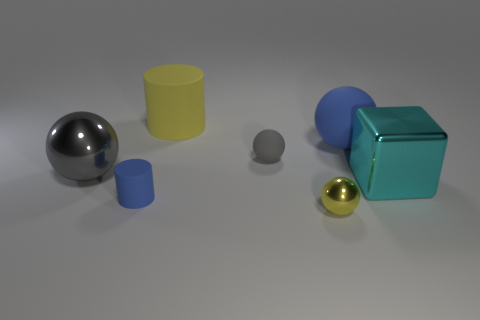What is the shape of the object that is both on the left side of the large yellow cylinder and in front of the big cyan thing?
Make the answer very short. Cylinder. There is a cylinder that is behind the matte ball left of the small yellow ball; how big is it?
Offer a terse response. Large. How many blue rubber objects are the same shape as the large gray metal object?
Make the answer very short. 1. Is the color of the small rubber sphere the same as the big metal ball?
Your response must be concise. Yes. Is there anything else that has the same shape as the big gray object?
Give a very brief answer. Yes. Is there a big matte cylinder that has the same color as the metallic block?
Make the answer very short. No. Is the material of the sphere that is to the right of the tiny yellow metal object the same as the thing that is in front of the blue cylinder?
Offer a very short reply. No. What is the color of the cube?
Offer a terse response. Cyan. There is a blue object on the left side of the matte cylinder behind the large ball left of the small blue rubber cylinder; what size is it?
Provide a succinct answer. Small. How many other objects are the same size as the blue cylinder?
Your answer should be very brief. 2. 